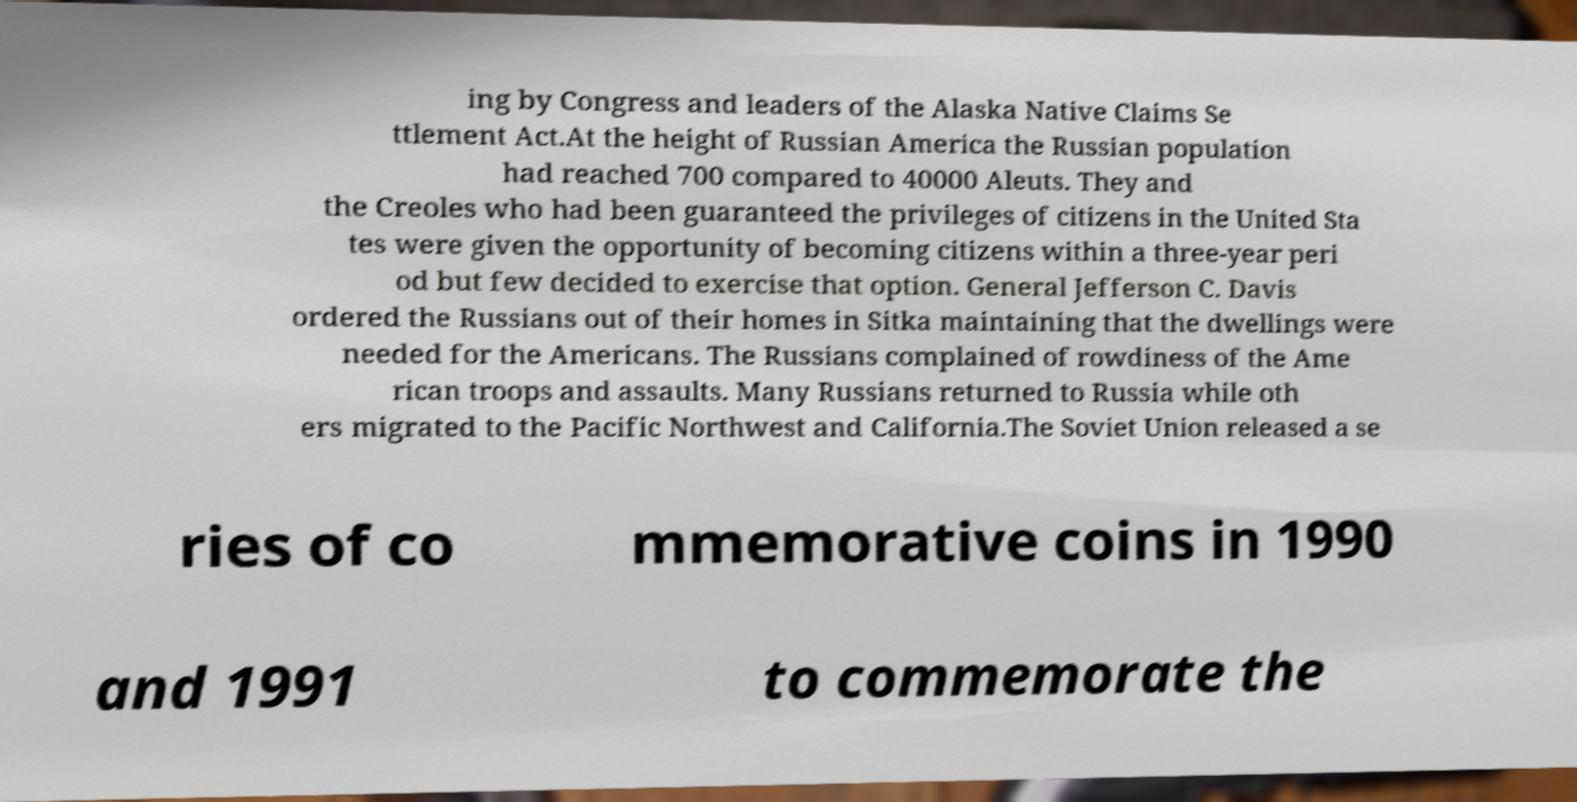What messages or text are displayed in this image? I need them in a readable, typed format. ing by Congress and leaders of the Alaska Native Claims Se ttlement Act.At the height of Russian America the Russian population had reached 700 compared to 40000 Aleuts. They and the Creoles who had been guaranteed the privileges of citizens in the United Sta tes were given the opportunity of becoming citizens within a three-year peri od but few decided to exercise that option. General Jefferson C. Davis ordered the Russians out of their homes in Sitka maintaining that the dwellings were needed for the Americans. The Russians complained of rowdiness of the Ame rican troops and assaults. Many Russians returned to Russia while oth ers migrated to the Pacific Northwest and California.The Soviet Union released a se ries of co mmemorative coins in 1990 and 1991 to commemorate the 